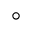Convert formula to latex. <formula><loc_0><loc_0><loc_500><loc_500>^ { \circ }</formula> 